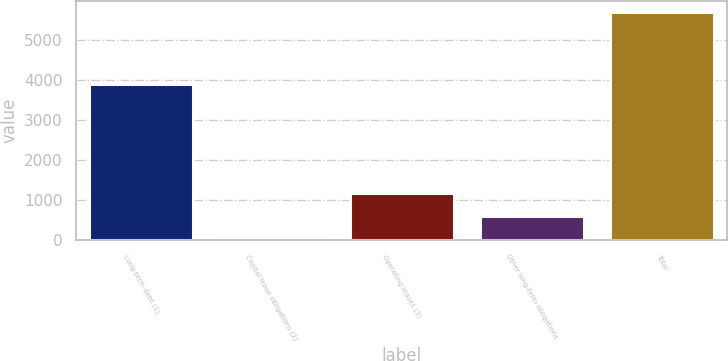Convert chart to OTSL. <chart><loc_0><loc_0><loc_500><loc_500><bar_chart><fcel>Long-term debt (1)<fcel>Capital lease obligations (2)<fcel>Operating leases (3)<fcel>Other long-term obligations<fcel>Total<nl><fcel>3897.5<fcel>24.8<fcel>1184.6<fcel>592.28<fcel>5699.6<nl></chart> 